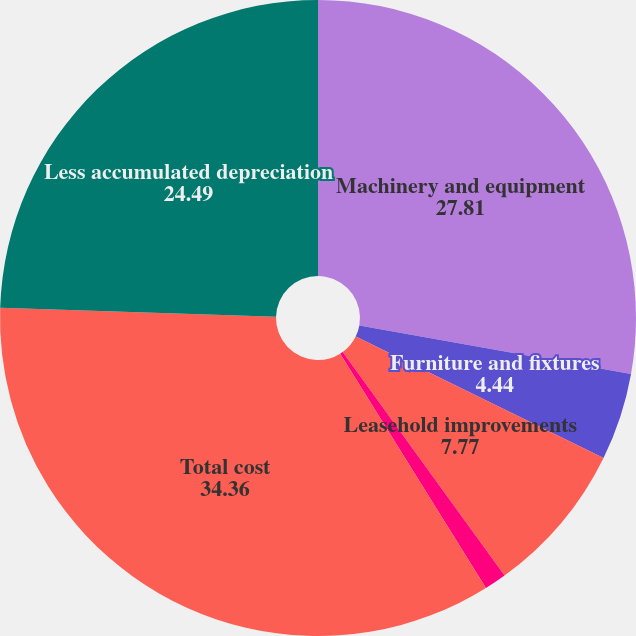<chart> <loc_0><loc_0><loc_500><loc_500><pie_chart><fcel>Machinery and equipment<fcel>Furniture and fixtures<fcel>Leasehold improvements<fcel>Construction in progress<fcel>Total cost<fcel>Less accumulated depreciation<nl><fcel>27.81%<fcel>4.44%<fcel>7.77%<fcel>1.12%<fcel>34.36%<fcel>24.49%<nl></chart> 